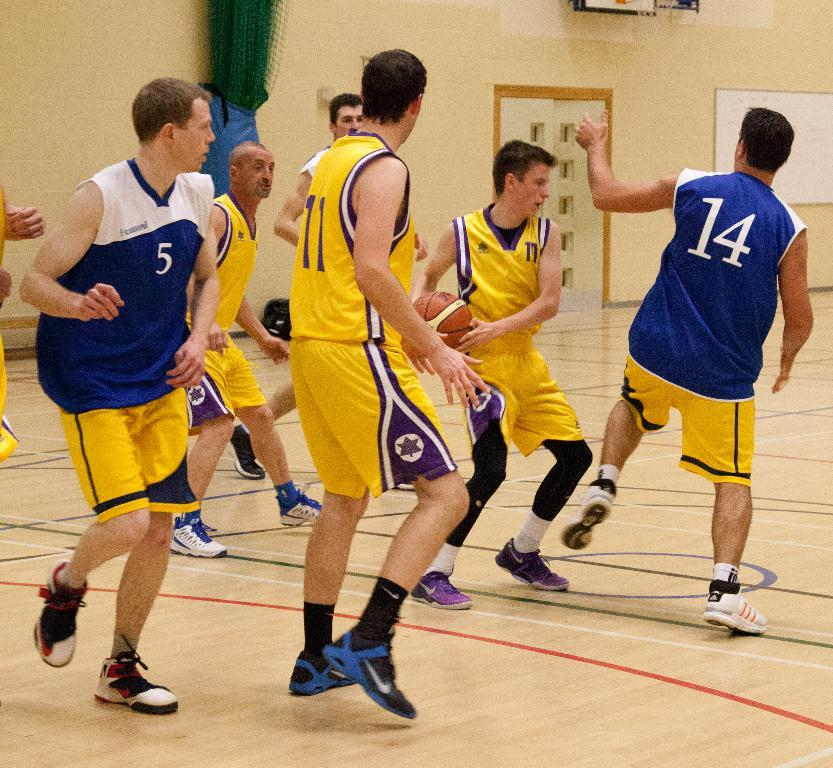<image>
Summarize the visual content of the image. Number 14 tries to swat the ball away from number 17. 